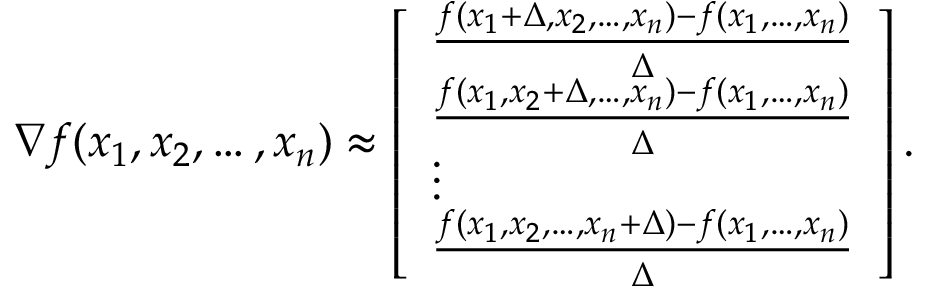Convert formula to latex. <formula><loc_0><loc_0><loc_500><loc_500>\nabla f ( x _ { 1 } , x _ { 2 } , \dots , x _ { n } ) \approx \left [ \begin{array} { l } { \frac { f ( x _ { 1 } + \Delta , x _ { 2 } , \dots , x _ { n } ) - f ( x _ { 1 } , \dots , x _ { n } ) } { \Delta } } \\ { \frac { f ( x _ { 1 } , x _ { 2 } + \Delta , \dots , x _ { n } ) - f ( x _ { 1 } , \dots , x _ { n } ) } { \Delta } } \\ { \vdots } \\ { \frac { f ( x _ { 1 } , x _ { 2 } , \dots , x _ { n } + \Delta ) - f ( x _ { 1 } , \dots , x _ { n } ) } { \Delta } } \end{array} \right ] .</formula> 